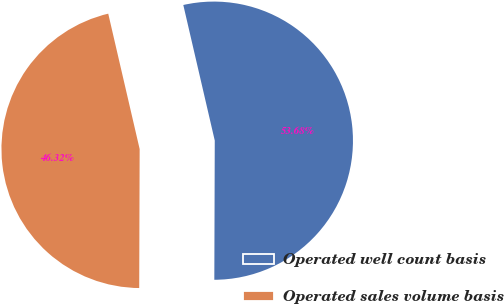Convert chart to OTSL. <chart><loc_0><loc_0><loc_500><loc_500><pie_chart><fcel>Operated well count basis<fcel>Operated sales volume basis<nl><fcel>53.68%<fcel>46.32%<nl></chart> 